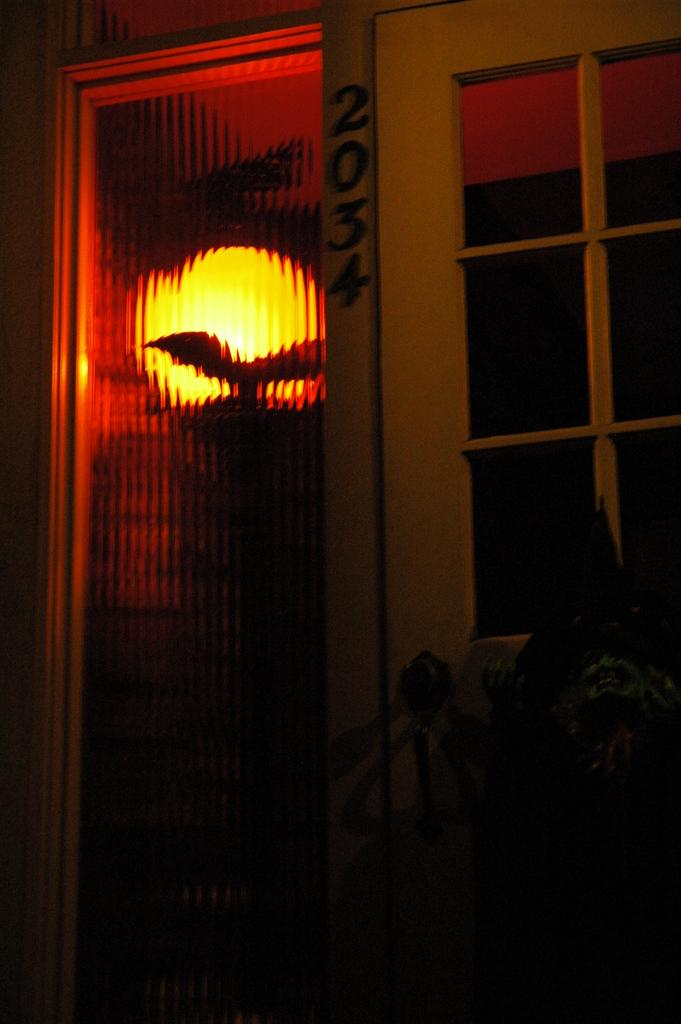What type of door is visible in the image? There is a glass door in the image. What is located behind the glass door? There is a lamp behind the glass door. Can you see any signs of quicksand in the image? There is no quicksand present in the image. Is there a person visible in the image? The provided facts do not mention a person being present in the image. 